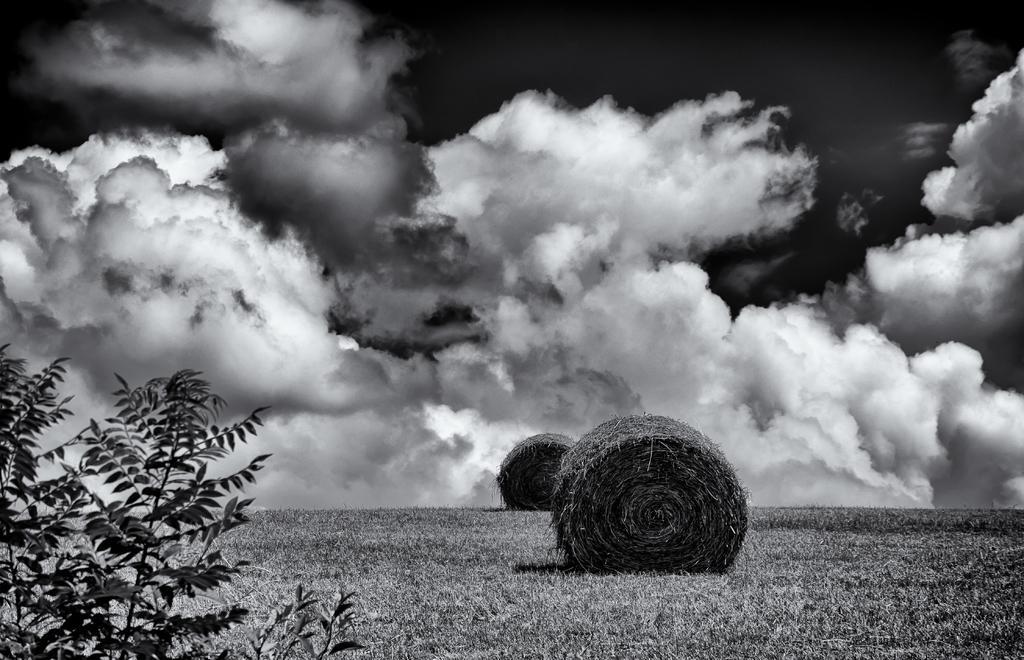Can you describe this image briefly? In this image in the front on the left side there are leaves in the center there are objects and the sky is cloudy. 